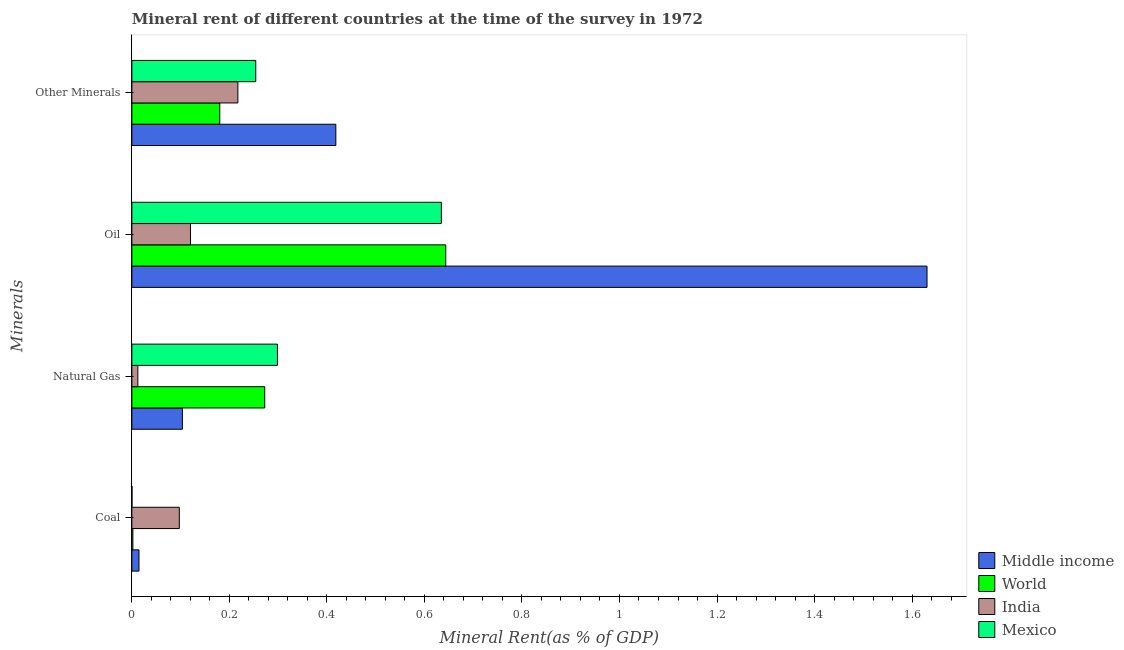How many different coloured bars are there?
Your answer should be compact. 4. How many groups of bars are there?
Your answer should be very brief. 4. Are the number of bars on each tick of the Y-axis equal?
Ensure brevity in your answer.  Yes. What is the label of the 2nd group of bars from the top?
Make the answer very short. Oil. What is the coal rent in World?
Give a very brief answer. 0. Across all countries, what is the maximum natural gas rent?
Your answer should be very brief. 0.3. Across all countries, what is the minimum coal rent?
Your answer should be compact. 0. What is the total  rent of other minerals in the graph?
Offer a terse response. 1.07. What is the difference between the oil rent in Mexico and that in India?
Offer a very short reply. 0.51. What is the difference between the  rent of other minerals in World and the natural gas rent in Mexico?
Provide a succinct answer. -0.12. What is the average natural gas rent per country?
Provide a succinct answer. 0.17. What is the difference between the coal rent and  rent of other minerals in Mexico?
Offer a terse response. -0.25. In how many countries, is the  rent of other minerals greater than 1.3200000000000003 %?
Make the answer very short. 0. What is the ratio of the coal rent in Middle income to that in India?
Your response must be concise. 0.15. Is the  rent of other minerals in India less than that in Mexico?
Keep it short and to the point. Yes. Is the difference between the oil rent in World and Middle income greater than the difference between the  rent of other minerals in World and Middle income?
Your response must be concise. No. What is the difference between the highest and the second highest natural gas rent?
Your answer should be compact. 0.03. What is the difference between the highest and the lowest coal rent?
Your answer should be compact. 0.1. In how many countries, is the natural gas rent greater than the average natural gas rent taken over all countries?
Keep it short and to the point. 2. Is the sum of the coal rent in India and Mexico greater than the maximum natural gas rent across all countries?
Your answer should be compact. No. Is it the case that in every country, the sum of the coal rent and natural gas rent is greater than the oil rent?
Make the answer very short. No. How many bars are there?
Offer a terse response. 16. Are the values on the major ticks of X-axis written in scientific E-notation?
Offer a terse response. No. Does the graph contain any zero values?
Give a very brief answer. No. Does the graph contain grids?
Offer a very short reply. No. How are the legend labels stacked?
Your answer should be very brief. Vertical. What is the title of the graph?
Your answer should be very brief. Mineral rent of different countries at the time of the survey in 1972. Does "Channel Islands" appear as one of the legend labels in the graph?
Your answer should be compact. No. What is the label or title of the X-axis?
Ensure brevity in your answer.  Mineral Rent(as % of GDP). What is the label or title of the Y-axis?
Provide a succinct answer. Minerals. What is the Mineral Rent(as % of GDP) in Middle income in Coal?
Your answer should be compact. 0.01. What is the Mineral Rent(as % of GDP) of World in Coal?
Your answer should be compact. 0. What is the Mineral Rent(as % of GDP) in India in Coal?
Make the answer very short. 0.1. What is the Mineral Rent(as % of GDP) in Mexico in Coal?
Offer a terse response. 0. What is the Mineral Rent(as % of GDP) in Middle income in Natural Gas?
Provide a succinct answer. 0.1. What is the Mineral Rent(as % of GDP) in World in Natural Gas?
Ensure brevity in your answer.  0.27. What is the Mineral Rent(as % of GDP) in India in Natural Gas?
Your answer should be compact. 0.01. What is the Mineral Rent(as % of GDP) in Mexico in Natural Gas?
Give a very brief answer. 0.3. What is the Mineral Rent(as % of GDP) in Middle income in Oil?
Your response must be concise. 1.63. What is the Mineral Rent(as % of GDP) of World in Oil?
Offer a terse response. 0.64. What is the Mineral Rent(as % of GDP) in India in Oil?
Make the answer very short. 0.12. What is the Mineral Rent(as % of GDP) in Mexico in Oil?
Make the answer very short. 0.63. What is the Mineral Rent(as % of GDP) of Middle income in Other Minerals?
Provide a short and direct response. 0.42. What is the Mineral Rent(as % of GDP) in World in Other Minerals?
Offer a very short reply. 0.18. What is the Mineral Rent(as % of GDP) in India in Other Minerals?
Your answer should be very brief. 0.22. What is the Mineral Rent(as % of GDP) in Mexico in Other Minerals?
Your answer should be very brief. 0.25. Across all Minerals, what is the maximum Mineral Rent(as % of GDP) of Middle income?
Your answer should be compact. 1.63. Across all Minerals, what is the maximum Mineral Rent(as % of GDP) of World?
Give a very brief answer. 0.64. Across all Minerals, what is the maximum Mineral Rent(as % of GDP) of India?
Give a very brief answer. 0.22. Across all Minerals, what is the maximum Mineral Rent(as % of GDP) in Mexico?
Make the answer very short. 0.63. Across all Minerals, what is the minimum Mineral Rent(as % of GDP) of Middle income?
Your answer should be compact. 0.01. Across all Minerals, what is the minimum Mineral Rent(as % of GDP) in World?
Keep it short and to the point. 0. Across all Minerals, what is the minimum Mineral Rent(as % of GDP) in India?
Give a very brief answer. 0.01. Across all Minerals, what is the minimum Mineral Rent(as % of GDP) in Mexico?
Give a very brief answer. 0. What is the total Mineral Rent(as % of GDP) of Middle income in the graph?
Offer a very short reply. 2.17. What is the total Mineral Rent(as % of GDP) in World in the graph?
Make the answer very short. 1.1. What is the total Mineral Rent(as % of GDP) in India in the graph?
Provide a short and direct response. 0.45. What is the total Mineral Rent(as % of GDP) of Mexico in the graph?
Offer a very short reply. 1.19. What is the difference between the Mineral Rent(as % of GDP) in Middle income in Coal and that in Natural Gas?
Offer a very short reply. -0.09. What is the difference between the Mineral Rent(as % of GDP) of World in Coal and that in Natural Gas?
Ensure brevity in your answer.  -0.27. What is the difference between the Mineral Rent(as % of GDP) of India in Coal and that in Natural Gas?
Ensure brevity in your answer.  0.09. What is the difference between the Mineral Rent(as % of GDP) in Mexico in Coal and that in Natural Gas?
Keep it short and to the point. -0.3. What is the difference between the Mineral Rent(as % of GDP) of Middle income in Coal and that in Oil?
Provide a short and direct response. -1.62. What is the difference between the Mineral Rent(as % of GDP) in World in Coal and that in Oil?
Give a very brief answer. -0.64. What is the difference between the Mineral Rent(as % of GDP) of India in Coal and that in Oil?
Your answer should be very brief. -0.02. What is the difference between the Mineral Rent(as % of GDP) in Mexico in Coal and that in Oil?
Provide a short and direct response. -0.63. What is the difference between the Mineral Rent(as % of GDP) in Middle income in Coal and that in Other Minerals?
Your response must be concise. -0.4. What is the difference between the Mineral Rent(as % of GDP) of World in Coal and that in Other Minerals?
Your answer should be very brief. -0.18. What is the difference between the Mineral Rent(as % of GDP) of India in Coal and that in Other Minerals?
Offer a terse response. -0.12. What is the difference between the Mineral Rent(as % of GDP) of Mexico in Coal and that in Other Minerals?
Your response must be concise. -0.25. What is the difference between the Mineral Rent(as % of GDP) in Middle income in Natural Gas and that in Oil?
Provide a succinct answer. -1.53. What is the difference between the Mineral Rent(as % of GDP) in World in Natural Gas and that in Oil?
Keep it short and to the point. -0.37. What is the difference between the Mineral Rent(as % of GDP) in India in Natural Gas and that in Oil?
Keep it short and to the point. -0.11. What is the difference between the Mineral Rent(as % of GDP) in Mexico in Natural Gas and that in Oil?
Offer a very short reply. -0.34. What is the difference between the Mineral Rent(as % of GDP) in Middle income in Natural Gas and that in Other Minerals?
Your answer should be compact. -0.31. What is the difference between the Mineral Rent(as % of GDP) in World in Natural Gas and that in Other Minerals?
Provide a short and direct response. 0.09. What is the difference between the Mineral Rent(as % of GDP) of India in Natural Gas and that in Other Minerals?
Provide a short and direct response. -0.21. What is the difference between the Mineral Rent(as % of GDP) in Mexico in Natural Gas and that in Other Minerals?
Your answer should be very brief. 0.04. What is the difference between the Mineral Rent(as % of GDP) of Middle income in Oil and that in Other Minerals?
Keep it short and to the point. 1.21. What is the difference between the Mineral Rent(as % of GDP) in World in Oil and that in Other Minerals?
Your answer should be very brief. 0.46. What is the difference between the Mineral Rent(as % of GDP) of India in Oil and that in Other Minerals?
Your answer should be very brief. -0.1. What is the difference between the Mineral Rent(as % of GDP) of Mexico in Oil and that in Other Minerals?
Your response must be concise. 0.38. What is the difference between the Mineral Rent(as % of GDP) in Middle income in Coal and the Mineral Rent(as % of GDP) in World in Natural Gas?
Give a very brief answer. -0.26. What is the difference between the Mineral Rent(as % of GDP) in Middle income in Coal and the Mineral Rent(as % of GDP) in India in Natural Gas?
Ensure brevity in your answer.  0. What is the difference between the Mineral Rent(as % of GDP) of Middle income in Coal and the Mineral Rent(as % of GDP) of Mexico in Natural Gas?
Give a very brief answer. -0.28. What is the difference between the Mineral Rent(as % of GDP) in World in Coal and the Mineral Rent(as % of GDP) in India in Natural Gas?
Offer a very short reply. -0.01. What is the difference between the Mineral Rent(as % of GDP) of World in Coal and the Mineral Rent(as % of GDP) of Mexico in Natural Gas?
Provide a succinct answer. -0.3. What is the difference between the Mineral Rent(as % of GDP) in India in Coal and the Mineral Rent(as % of GDP) in Mexico in Natural Gas?
Your answer should be compact. -0.2. What is the difference between the Mineral Rent(as % of GDP) in Middle income in Coal and the Mineral Rent(as % of GDP) in World in Oil?
Provide a short and direct response. -0.63. What is the difference between the Mineral Rent(as % of GDP) in Middle income in Coal and the Mineral Rent(as % of GDP) in India in Oil?
Provide a succinct answer. -0.11. What is the difference between the Mineral Rent(as % of GDP) in Middle income in Coal and the Mineral Rent(as % of GDP) in Mexico in Oil?
Keep it short and to the point. -0.62. What is the difference between the Mineral Rent(as % of GDP) in World in Coal and the Mineral Rent(as % of GDP) in India in Oil?
Provide a short and direct response. -0.12. What is the difference between the Mineral Rent(as % of GDP) in World in Coal and the Mineral Rent(as % of GDP) in Mexico in Oil?
Give a very brief answer. -0.63. What is the difference between the Mineral Rent(as % of GDP) of India in Coal and the Mineral Rent(as % of GDP) of Mexico in Oil?
Offer a very short reply. -0.54. What is the difference between the Mineral Rent(as % of GDP) of Middle income in Coal and the Mineral Rent(as % of GDP) of World in Other Minerals?
Ensure brevity in your answer.  -0.17. What is the difference between the Mineral Rent(as % of GDP) in Middle income in Coal and the Mineral Rent(as % of GDP) in India in Other Minerals?
Provide a short and direct response. -0.2. What is the difference between the Mineral Rent(as % of GDP) of Middle income in Coal and the Mineral Rent(as % of GDP) of Mexico in Other Minerals?
Offer a terse response. -0.24. What is the difference between the Mineral Rent(as % of GDP) in World in Coal and the Mineral Rent(as % of GDP) in India in Other Minerals?
Your response must be concise. -0.22. What is the difference between the Mineral Rent(as % of GDP) of World in Coal and the Mineral Rent(as % of GDP) of Mexico in Other Minerals?
Give a very brief answer. -0.25. What is the difference between the Mineral Rent(as % of GDP) in India in Coal and the Mineral Rent(as % of GDP) in Mexico in Other Minerals?
Provide a succinct answer. -0.16. What is the difference between the Mineral Rent(as % of GDP) in Middle income in Natural Gas and the Mineral Rent(as % of GDP) in World in Oil?
Your answer should be compact. -0.54. What is the difference between the Mineral Rent(as % of GDP) in Middle income in Natural Gas and the Mineral Rent(as % of GDP) in India in Oil?
Give a very brief answer. -0.02. What is the difference between the Mineral Rent(as % of GDP) of Middle income in Natural Gas and the Mineral Rent(as % of GDP) of Mexico in Oil?
Provide a short and direct response. -0.53. What is the difference between the Mineral Rent(as % of GDP) in World in Natural Gas and the Mineral Rent(as % of GDP) in India in Oil?
Make the answer very short. 0.15. What is the difference between the Mineral Rent(as % of GDP) of World in Natural Gas and the Mineral Rent(as % of GDP) of Mexico in Oil?
Your response must be concise. -0.36. What is the difference between the Mineral Rent(as % of GDP) of India in Natural Gas and the Mineral Rent(as % of GDP) of Mexico in Oil?
Your response must be concise. -0.62. What is the difference between the Mineral Rent(as % of GDP) of Middle income in Natural Gas and the Mineral Rent(as % of GDP) of World in Other Minerals?
Make the answer very short. -0.08. What is the difference between the Mineral Rent(as % of GDP) in Middle income in Natural Gas and the Mineral Rent(as % of GDP) in India in Other Minerals?
Your answer should be compact. -0.11. What is the difference between the Mineral Rent(as % of GDP) in Middle income in Natural Gas and the Mineral Rent(as % of GDP) in Mexico in Other Minerals?
Give a very brief answer. -0.15. What is the difference between the Mineral Rent(as % of GDP) of World in Natural Gas and the Mineral Rent(as % of GDP) of India in Other Minerals?
Offer a very short reply. 0.06. What is the difference between the Mineral Rent(as % of GDP) in World in Natural Gas and the Mineral Rent(as % of GDP) in Mexico in Other Minerals?
Provide a succinct answer. 0.02. What is the difference between the Mineral Rent(as % of GDP) of India in Natural Gas and the Mineral Rent(as % of GDP) of Mexico in Other Minerals?
Your response must be concise. -0.24. What is the difference between the Mineral Rent(as % of GDP) in Middle income in Oil and the Mineral Rent(as % of GDP) in World in Other Minerals?
Your response must be concise. 1.45. What is the difference between the Mineral Rent(as % of GDP) in Middle income in Oil and the Mineral Rent(as % of GDP) in India in Other Minerals?
Your answer should be compact. 1.41. What is the difference between the Mineral Rent(as % of GDP) of Middle income in Oil and the Mineral Rent(as % of GDP) of Mexico in Other Minerals?
Give a very brief answer. 1.38. What is the difference between the Mineral Rent(as % of GDP) of World in Oil and the Mineral Rent(as % of GDP) of India in Other Minerals?
Your answer should be very brief. 0.43. What is the difference between the Mineral Rent(as % of GDP) of World in Oil and the Mineral Rent(as % of GDP) of Mexico in Other Minerals?
Your response must be concise. 0.39. What is the difference between the Mineral Rent(as % of GDP) in India in Oil and the Mineral Rent(as % of GDP) in Mexico in Other Minerals?
Provide a succinct answer. -0.13. What is the average Mineral Rent(as % of GDP) of Middle income per Minerals?
Give a very brief answer. 0.54. What is the average Mineral Rent(as % of GDP) of World per Minerals?
Ensure brevity in your answer.  0.27. What is the average Mineral Rent(as % of GDP) in India per Minerals?
Provide a short and direct response. 0.11. What is the average Mineral Rent(as % of GDP) of Mexico per Minerals?
Your answer should be very brief. 0.3. What is the difference between the Mineral Rent(as % of GDP) in Middle income and Mineral Rent(as % of GDP) in World in Coal?
Make the answer very short. 0.01. What is the difference between the Mineral Rent(as % of GDP) of Middle income and Mineral Rent(as % of GDP) of India in Coal?
Offer a terse response. -0.08. What is the difference between the Mineral Rent(as % of GDP) in Middle income and Mineral Rent(as % of GDP) in Mexico in Coal?
Make the answer very short. 0.01. What is the difference between the Mineral Rent(as % of GDP) in World and Mineral Rent(as % of GDP) in India in Coal?
Offer a very short reply. -0.1. What is the difference between the Mineral Rent(as % of GDP) of World and Mineral Rent(as % of GDP) of Mexico in Coal?
Your answer should be very brief. 0. What is the difference between the Mineral Rent(as % of GDP) in India and Mineral Rent(as % of GDP) in Mexico in Coal?
Your response must be concise. 0.1. What is the difference between the Mineral Rent(as % of GDP) in Middle income and Mineral Rent(as % of GDP) in World in Natural Gas?
Give a very brief answer. -0.17. What is the difference between the Mineral Rent(as % of GDP) in Middle income and Mineral Rent(as % of GDP) in India in Natural Gas?
Provide a short and direct response. 0.09. What is the difference between the Mineral Rent(as % of GDP) in Middle income and Mineral Rent(as % of GDP) in Mexico in Natural Gas?
Keep it short and to the point. -0.2. What is the difference between the Mineral Rent(as % of GDP) in World and Mineral Rent(as % of GDP) in India in Natural Gas?
Keep it short and to the point. 0.26. What is the difference between the Mineral Rent(as % of GDP) in World and Mineral Rent(as % of GDP) in Mexico in Natural Gas?
Give a very brief answer. -0.03. What is the difference between the Mineral Rent(as % of GDP) of India and Mineral Rent(as % of GDP) of Mexico in Natural Gas?
Keep it short and to the point. -0.29. What is the difference between the Mineral Rent(as % of GDP) of Middle income and Mineral Rent(as % of GDP) of World in Oil?
Provide a short and direct response. 0.99. What is the difference between the Mineral Rent(as % of GDP) in Middle income and Mineral Rent(as % of GDP) in India in Oil?
Keep it short and to the point. 1.51. What is the difference between the Mineral Rent(as % of GDP) of Middle income and Mineral Rent(as % of GDP) of Mexico in Oil?
Offer a terse response. 1. What is the difference between the Mineral Rent(as % of GDP) in World and Mineral Rent(as % of GDP) in India in Oil?
Ensure brevity in your answer.  0.52. What is the difference between the Mineral Rent(as % of GDP) in World and Mineral Rent(as % of GDP) in Mexico in Oil?
Offer a very short reply. 0.01. What is the difference between the Mineral Rent(as % of GDP) of India and Mineral Rent(as % of GDP) of Mexico in Oil?
Your answer should be very brief. -0.51. What is the difference between the Mineral Rent(as % of GDP) of Middle income and Mineral Rent(as % of GDP) of World in Other Minerals?
Provide a short and direct response. 0.24. What is the difference between the Mineral Rent(as % of GDP) of Middle income and Mineral Rent(as % of GDP) of India in Other Minerals?
Your answer should be compact. 0.2. What is the difference between the Mineral Rent(as % of GDP) in Middle income and Mineral Rent(as % of GDP) in Mexico in Other Minerals?
Your answer should be very brief. 0.16. What is the difference between the Mineral Rent(as % of GDP) of World and Mineral Rent(as % of GDP) of India in Other Minerals?
Ensure brevity in your answer.  -0.04. What is the difference between the Mineral Rent(as % of GDP) of World and Mineral Rent(as % of GDP) of Mexico in Other Minerals?
Provide a succinct answer. -0.07. What is the difference between the Mineral Rent(as % of GDP) in India and Mineral Rent(as % of GDP) in Mexico in Other Minerals?
Your response must be concise. -0.04. What is the ratio of the Mineral Rent(as % of GDP) of Middle income in Coal to that in Natural Gas?
Offer a very short reply. 0.14. What is the ratio of the Mineral Rent(as % of GDP) of World in Coal to that in Natural Gas?
Provide a succinct answer. 0.01. What is the ratio of the Mineral Rent(as % of GDP) of India in Coal to that in Natural Gas?
Your answer should be compact. 7.95. What is the ratio of the Mineral Rent(as % of GDP) of Middle income in Coal to that in Oil?
Your response must be concise. 0.01. What is the ratio of the Mineral Rent(as % of GDP) in World in Coal to that in Oil?
Give a very brief answer. 0. What is the ratio of the Mineral Rent(as % of GDP) of India in Coal to that in Oil?
Keep it short and to the point. 0.81. What is the ratio of the Mineral Rent(as % of GDP) in Mexico in Coal to that in Oil?
Keep it short and to the point. 0. What is the ratio of the Mineral Rent(as % of GDP) of Middle income in Coal to that in Other Minerals?
Offer a very short reply. 0.03. What is the ratio of the Mineral Rent(as % of GDP) of World in Coal to that in Other Minerals?
Your answer should be compact. 0.01. What is the ratio of the Mineral Rent(as % of GDP) of India in Coal to that in Other Minerals?
Your answer should be very brief. 0.45. What is the ratio of the Mineral Rent(as % of GDP) in Mexico in Coal to that in Other Minerals?
Your answer should be compact. 0. What is the ratio of the Mineral Rent(as % of GDP) in Middle income in Natural Gas to that in Oil?
Keep it short and to the point. 0.06. What is the ratio of the Mineral Rent(as % of GDP) in World in Natural Gas to that in Oil?
Keep it short and to the point. 0.42. What is the ratio of the Mineral Rent(as % of GDP) of India in Natural Gas to that in Oil?
Your answer should be compact. 0.1. What is the ratio of the Mineral Rent(as % of GDP) of Mexico in Natural Gas to that in Oil?
Provide a succinct answer. 0.47. What is the ratio of the Mineral Rent(as % of GDP) in Middle income in Natural Gas to that in Other Minerals?
Your response must be concise. 0.25. What is the ratio of the Mineral Rent(as % of GDP) of World in Natural Gas to that in Other Minerals?
Ensure brevity in your answer.  1.51. What is the ratio of the Mineral Rent(as % of GDP) in India in Natural Gas to that in Other Minerals?
Keep it short and to the point. 0.06. What is the ratio of the Mineral Rent(as % of GDP) in Mexico in Natural Gas to that in Other Minerals?
Provide a succinct answer. 1.18. What is the ratio of the Mineral Rent(as % of GDP) of Middle income in Oil to that in Other Minerals?
Your response must be concise. 3.9. What is the ratio of the Mineral Rent(as % of GDP) of World in Oil to that in Other Minerals?
Provide a short and direct response. 3.57. What is the ratio of the Mineral Rent(as % of GDP) in India in Oil to that in Other Minerals?
Your answer should be very brief. 0.55. What is the ratio of the Mineral Rent(as % of GDP) in Mexico in Oil to that in Other Minerals?
Offer a terse response. 2.5. What is the difference between the highest and the second highest Mineral Rent(as % of GDP) of Middle income?
Ensure brevity in your answer.  1.21. What is the difference between the highest and the second highest Mineral Rent(as % of GDP) in World?
Your answer should be compact. 0.37. What is the difference between the highest and the second highest Mineral Rent(as % of GDP) in India?
Keep it short and to the point. 0.1. What is the difference between the highest and the second highest Mineral Rent(as % of GDP) of Mexico?
Keep it short and to the point. 0.34. What is the difference between the highest and the lowest Mineral Rent(as % of GDP) of Middle income?
Ensure brevity in your answer.  1.62. What is the difference between the highest and the lowest Mineral Rent(as % of GDP) of World?
Ensure brevity in your answer.  0.64. What is the difference between the highest and the lowest Mineral Rent(as % of GDP) of India?
Provide a short and direct response. 0.21. What is the difference between the highest and the lowest Mineral Rent(as % of GDP) of Mexico?
Make the answer very short. 0.63. 